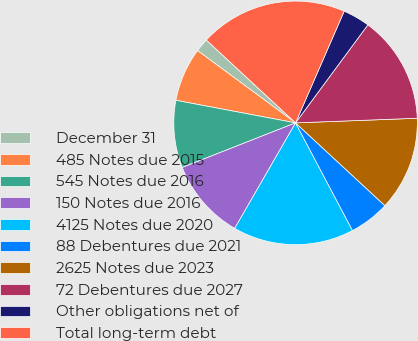Convert chart to OTSL. <chart><loc_0><loc_0><loc_500><loc_500><pie_chart><fcel>December 31<fcel>485 Notes due 2015<fcel>545 Notes due 2016<fcel>150 Notes due 2016<fcel>4125 Notes due 2020<fcel>88 Debentures due 2021<fcel>2625 Notes due 2023<fcel>72 Debentures due 2027<fcel>Other obligations net of<fcel>Total long-term debt<nl><fcel>1.79%<fcel>7.15%<fcel>8.93%<fcel>10.71%<fcel>16.07%<fcel>5.36%<fcel>12.5%<fcel>14.28%<fcel>3.58%<fcel>19.63%<nl></chart> 